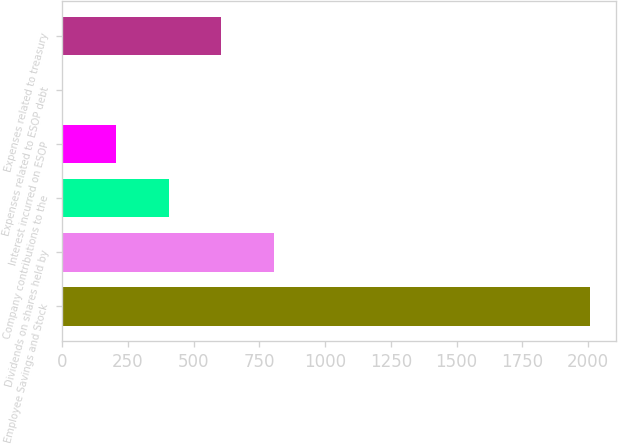Convert chart. <chart><loc_0><loc_0><loc_500><loc_500><bar_chart><fcel>Employee Savings and Stock<fcel>Dividends on shares held by<fcel>Company contributions to the<fcel>Interest incurred on ESOP<fcel>Expenses related to ESOP debt<fcel>Expenses related to treasury<nl><fcel>2006<fcel>804.8<fcel>404.4<fcel>204.2<fcel>4<fcel>604.6<nl></chart> 